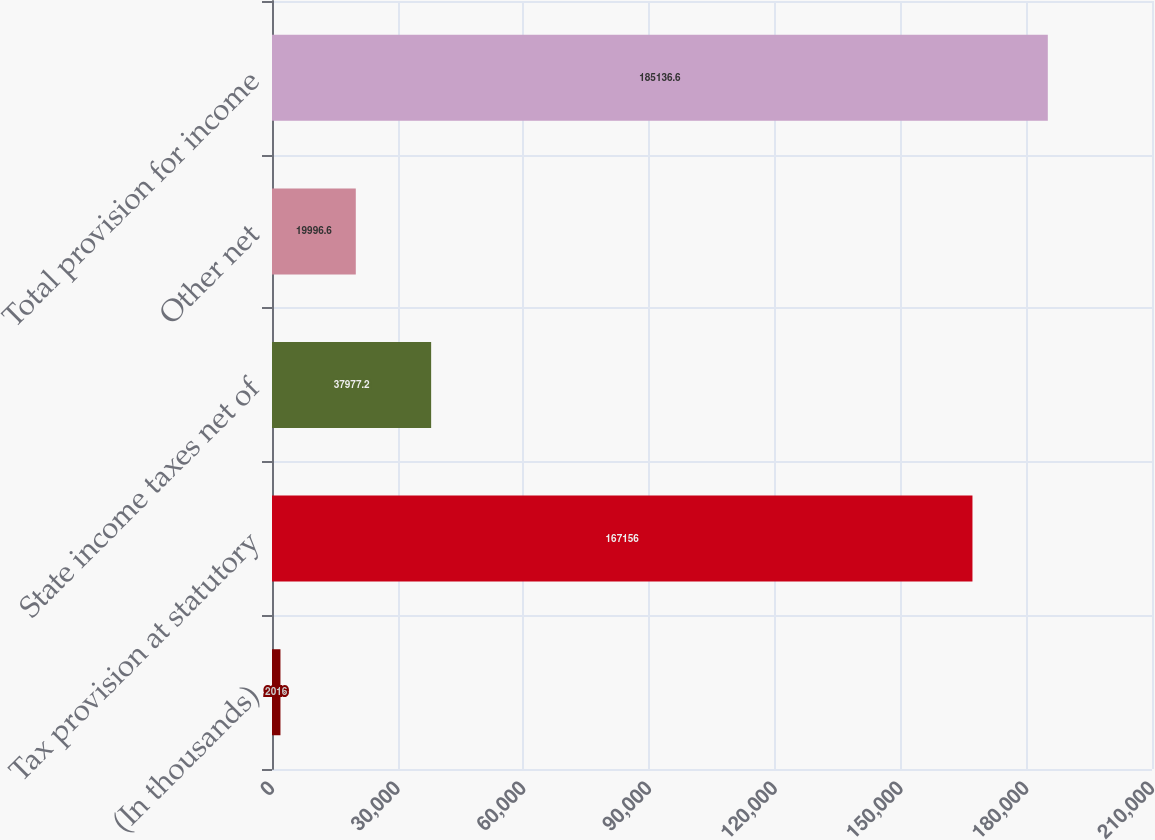Convert chart. <chart><loc_0><loc_0><loc_500><loc_500><bar_chart><fcel>(In thousands)<fcel>Tax provision at statutory<fcel>State income taxes net of<fcel>Other net<fcel>Total provision for income<nl><fcel>2016<fcel>167156<fcel>37977.2<fcel>19996.6<fcel>185137<nl></chart> 